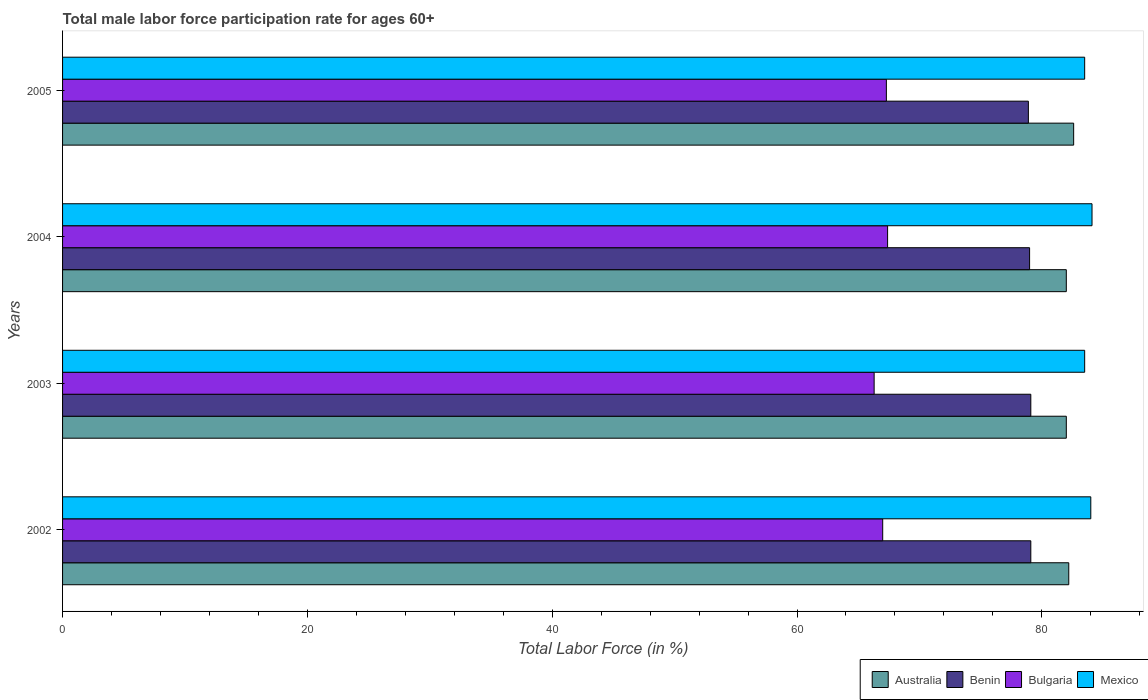How many groups of bars are there?
Offer a very short reply. 4. Are the number of bars on each tick of the Y-axis equal?
Provide a short and direct response. Yes. What is the male labor force participation rate in Australia in 2002?
Offer a very short reply. 82.2. Across all years, what is the maximum male labor force participation rate in Benin?
Keep it short and to the point. 79.1. Across all years, what is the minimum male labor force participation rate in Bulgaria?
Provide a succinct answer. 66.3. In which year was the male labor force participation rate in Mexico minimum?
Ensure brevity in your answer.  2003. What is the total male labor force participation rate in Benin in the graph?
Provide a succinct answer. 316.1. What is the difference between the male labor force participation rate in Bulgaria in 2002 and that in 2003?
Your response must be concise. 0.7. What is the difference between the male labor force participation rate in Australia in 2004 and the male labor force participation rate in Benin in 2003?
Offer a very short reply. 2.9. What is the average male labor force participation rate in Bulgaria per year?
Your answer should be compact. 67. In the year 2005, what is the difference between the male labor force participation rate in Benin and male labor force participation rate in Australia?
Keep it short and to the point. -3.7. In how many years, is the male labor force participation rate in Mexico greater than 4 %?
Offer a terse response. 4. What is the ratio of the male labor force participation rate in Bulgaria in 2003 to that in 2004?
Provide a short and direct response. 0.98. Is the male labor force participation rate in Benin in 2002 less than that in 2004?
Give a very brief answer. No. What is the difference between the highest and the second highest male labor force participation rate in Mexico?
Ensure brevity in your answer.  0.1. What is the difference between the highest and the lowest male labor force participation rate in Australia?
Your response must be concise. 0.6. In how many years, is the male labor force participation rate in Bulgaria greater than the average male labor force participation rate in Bulgaria taken over all years?
Your answer should be very brief. 2. Is the sum of the male labor force participation rate in Bulgaria in 2003 and 2005 greater than the maximum male labor force participation rate in Mexico across all years?
Offer a very short reply. Yes. Is it the case that in every year, the sum of the male labor force participation rate in Mexico and male labor force participation rate in Benin is greater than the sum of male labor force participation rate in Australia and male labor force participation rate in Bulgaria?
Keep it short and to the point. No. What does the 1st bar from the bottom in 2003 represents?
Give a very brief answer. Australia. Is it the case that in every year, the sum of the male labor force participation rate in Bulgaria and male labor force participation rate in Mexico is greater than the male labor force participation rate in Benin?
Your answer should be compact. Yes. Does the graph contain any zero values?
Give a very brief answer. No. Does the graph contain grids?
Keep it short and to the point. No. How are the legend labels stacked?
Provide a succinct answer. Horizontal. What is the title of the graph?
Your answer should be very brief. Total male labor force participation rate for ages 60+. What is the label or title of the X-axis?
Make the answer very short. Total Labor Force (in %). What is the Total Labor Force (in %) in Australia in 2002?
Offer a very short reply. 82.2. What is the Total Labor Force (in %) of Benin in 2002?
Ensure brevity in your answer.  79.1. What is the Total Labor Force (in %) in Bulgaria in 2002?
Your answer should be compact. 67. What is the Total Labor Force (in %) in Mexico in 2002?
Offer a very short reply. 84. What is the Total Labor Force (in %) of Australia in 2003?
Your answer should be compact. 82. What is the Total Labor Force (in %) of Benin in 2003?
Keep it short and to the point. 79.1. What is the Total Labor Force (in %) of Bulgaria in 2003?
Offer a terse response. 66.3. What is the Total Labor Force (in %) of Mexico in 2003?
Provide a short and direct response. 83.5. What is the Total Labor Force (in %) of Benin in 2004?
Ensure brevity in your answer.  79. What is the Total Labor Force (in %) in Bulgaria in 2004?
Keep it short and to the point. 67.4. What is the Total Labor Force (in %) of Mexico in 2004?
Your answer should be compact. 84.1. What is the Total Labor Force (in %) of Australia in 2005?
Make the answer very short. 82.6. What is the Total Labor Force (in %) in Benin in 2005?
Keep it short and to the point. 78.9. What is the Total Labor Force (in %) in Bulgaria in 2005?
Provide a succinct answer. 67.3. What is the Total Labor Force (in %) in Mexico in 2005?
Your answer should be very brief. 83.5. Across all years, what is the maximum Total Labor Force (in %) of Australia?
Make the answer very short. 82.6. Across all years, what is the maximum Total Labor Force (in %) in Benin?
Offer a terse response. 79.1. Across all years, what is the maximum Total Labor Force (in %) of Bulgaria?
Provide a short and direct response. 67.4. Across all years, what is the maximum Total Labor Force (in %) of Mexico?
Provide a short and direct response. 84.1. Across all years, what is the minimum Total Labor Force (in %) in Benin?
Make the answer very short. 78.9. Across all years, what is the minimum Total Labor Force (in %) of Bulgaria?
Give a very brief answer. 66.3. Across all years, what is the minimum Total Labor Force (in %) in Mexico?
Your response must be concise. 83.5. What is the total Total Labor Force (in %) of Australia in the graph?
Make the answer very short. 328.8. What is the total Total Labor Force (in %) in Benin in the graph?
Offer a terse response. 316.1. What is the total Total Labor Force (in %) in Bulgaria in the graph?
Keep it short and to the point. 268. What is the total Total Labor Force (in %) in Mexico in the graph?
Offer a very short reply. 335.1. What is the difference between the Total Labor Force (in %) in Australia in 2002 and that in 2003?
Offer a very short reply. 0.2. What is the difference between the Total Labor Force (in %) of Benin in 2002 and that in 2003?
Give a very brief answer. 0. What is the difference between the Total Labor Force (in %) in Australia in 2002 and that in 2004?
Ensure brevity in your answer.  0.2. What is the difference between the Total Labor Force (in %) in Benin in 2002 and that in 2004?
Offer a very short reply. 0.1. What is the difference between the Total Labor Force (in %) of Mexico in 2002 and that in 2004?
Keep it short and to the point. -0.1. What is the difference between the Total Labor Force (in %) in Australia in 2002 and that in 2005?
Offer a terse response. -0.4. What is the difference between the Total Labor Force (in %) of Benin in 2002 and that in 2005?
Offer a terse response. 0.2. What is the difference between the Total Labor Force (in %) of Mexico in 2002 and that in 2005?
Provide a short and direct response. 0.5. What is the difference between the Total Labor Force (in %) in Benin in 2003 and that in 2004?
Ensure brevity in your answer.  0.1. What is the difference between the Total Labor Force (in %) of Bulgaria in 2003 and that in 2004?
Make the answer very short. -1.1. What is the difference between the Total Labor Force (in %) of Mexico in 2003 and that in 2004?
Your answer should be very brief. -0.6. What is the difference between the Total Labor Force (in %) in Bulgaria in 2003 and that in 2005?
Keep it short and to the point. -1. What is the difference between the Total Labor Force (in %) in Mexico in 2003 and that in 2005?
Your answer should be very brief. 0. What is the difference between the Total Labor Force (in %) in Australia in 2004 and that in 2005?
Provide a short and direct response. -0.6. What is the difference between the Total Labor Force (in %) in Benin in 2004 and that in 2005?
Ensure brevity in your answer.  0.1. What is the difference between the Total Labor Force (in %) in Bulgaria in 2004 and that in 2005?
Offer a terse response. 0.1. What is the difference between the Total Labor Force (in %) of Mexico in 2004 and that in 2005?
Keep it short and to the point. 0.6. What is the difference between the Total Labor Force (in %) in Australia in 2002 and the Total Labor Force (in %) in Benin in 2003?
Provide a succinct answer. 3.1. What is the difference between the Total Labor Force (in %) of Australia in 2002 and the Total Labor Force (in %) of Bulgaria in 2003?
Make the answer very short. 15.9. What is the difference between the Total Labor Force (in %) in Australia in 2002 and the Total Labor Force (in %) in Mexico in 2003?
Ensure brevity in your answer.  -1.3. What is the difference between the Total Labor Force (in %) in Benin in 2002 and the Total Labor Force (in %) in Mexico in 2003?
Make the answer very short. -4.4. What is the difference between the Total Labor Force (in %) in Bulgaria in 2002 and the Total Labor Force (in %) in Mexico in 2003?
Your response must be concise. -16.5. What is the difference between the Total Labor Force (in %) in Australia in 2002 and the Total Labor Force (in %) in Benin in 2004?
Offer a very short reply. 3.2. What is the difference between the Total Labor Force (in %) in Australia in 2002 and the Total Labor Force (in %) in Bulgaria in 2004?
Ensure brevity in your answer.  14.8. What is the difference between the Total Labor Force (in %) in Benin in 2002 and the Total Labor Force (in %) in Mexico in 2004?
Provide a succinct answer. -5. What is the difference between the Total Labor Force (in %) of Bulgaria in 2002 and the Total Labor Force (in %) of Mexico in 2004?
Ensure brevity in your answer.  -17.1. What is the difference between the Total Labor Force (in %) of Australia in 2002 and the Total Labor Force (in %) of Mexico in 2005?
Give a very brief answer. -1.3. What is the difference between the Total Labor Force (in %) in Benin in 2002 and the Total Labor Force (in %) in Mexico in 2005?
Give a very brief answer. -4.4. What is the difference between the Total Labor Force (in %) of Bulgaria in 2002 and the Total Labor Force (in %) of Mexico in 2005?
Ensure brevity in your answer.  -16.5. What is the difference between the Total Labor Force (in %) of Australia in 2003 and the Total Labor Force (in %) of Benin in 2004?
Give a very brief answer. 3. What is the difference between the Total Labor Force (in %) in Australia in 2003 and the Total Labor Force (in %) in Mexico in 2004?
Ensure brevity in your answer.  -2.1. What is the difference between the Total Labor Force (in %) of Benin in 2003 and the Total Labor Force (in %) of Bulgaria in 2004?
Your answer should be compact. 11.7. What is the difference between the Total Labor Force (in %) of Benin in 2003 and the Total Labor Force (in %) of Mexico in 2004?
Your response must be concise. -5. What is the difference between the Total Labor Force (in %) of Bulgaria in 2003 and the Total Labor Force (in %) of Mexico in 2004?
Your answer should be very brief. -17.8. What is the difference between the Total Labor Force (in %) in Australia in 2003 and the Total Labor Force (in %) in Benin in 2005?
Ensure brevity in your answer.  3.1. What is the difference between the Total Labor Force (in %) in Benin in 2003 and the Total Labor Force (in %) in Bulgaria in 2005?
Your response must be concise. 11.8. What is the difference between the Total Labor Force (in %) in Benin in 2003 and the Total Labor Force (in %) in Mexico in 2005?
Your answer should be compact. -4.4. What is the difference between the Total Labor Force (in %) in Bulgaria in 2003 and the Total Labor Force (in %) in Mexico in 2005?
Your answer should be very brief. -17.2. What is the difference between the Total Labor Force (in %) in Australia in 2004 and the Total Labor Force (in %) in Bulgaria in 2005?
Make the answer very short. 14.7. What is the difference between the Total Labor Force (in %) of Australia in 2004 and the Total Labor Force (in %) of Mexico in 2005?
Offer a very short reply. -1.5. What is the difference between the Total Labor Force (in %) of Benin in 2004 and the Total Labor Force (in %) of Bulgaria in 2005?
Your answer should be compact. 11.7. What is the difference between the Total Labor Force (in %) of Bulgaria in 2004 and the Total Labor Force (in %) of Mexico in 2005?
Provide a succinct answer. -16.1. What is the average Total Labor Force (in %) of Australia per year?
Keep it short and to the point. 82.2. What is the average Total Labor Force (in %) in Benin per year?
Your answer should be compact. 79.03. What is the average Total Labor Force (in %) in Mexico per year?
Keep it short and to the point. 83.78. In the year 2002, what is the difference between the Total Labor Force (in %) in Benin and Total Labor Force (in %) in Bulgaria?
Your answer should be compact. 12.1. In the year 2003, what is the difference between the Total Labor Force (in %) in Australia and Total Labor Force (in %) in Benin?
Ensure brevity in your answer.  2.9. In the year 2003, what is the difference between the Total Labor Force (in %) in Australia and Total Labor Force (in %) in Bulgaria?
Keep it short and to the point. 15.7. In the year 2003, what is the difference between the Total Labor Force (in %) in Australia and Total Labor Force (in %) in Mexico?
Your response must be concise. -1.5. In the year 2003, what is the difference between the Total Labor Force (in %) in Bulgaria and Total Labor Force (in %) in Mexico?
Your answer should be compact. -17.2. In the year 2004, what is the difference between the Total Labor Force (in %) of Benin and Total Labor Force (in %) of Bulgaria?
Ensure brevity in your answer.  11.6. In the year 2004, what is the difference between the Total Labor Force (in %) in Bulgaria and Total Labor Force (in %) in Mexico?
Offer a terse response. -16.7. In the year 2005, what is the difference between the Total Labor Force (in %) of Australia and Total Labor Force (in %) of Benin?
Make the answer very short. 3.7. In the year 2005, what is the difference between the Total Labor Force (in %) of Bulgaria and Total Labor Force (in %) of Mexico?
Your answer should be compact. -16.2. What is the ratio of the Total Labor Force (in %) in Australia in 2002 to that in 2003?
Make the answer very short. 1. What is the ratio of the Total Labor Force (in %) of Benin in 2002 to that in 2003?
Your response must be concise. 1. What is the ratio of the Total Labor Force (in %) of Bulgaria in 2002 to that in 2003?
Your answer should be compact. 1.01. What is the ratio of the Total Labor Force (in %) of Mexico in 2002 to that in 2003?
Your answer should be very brief. 1.01. What is the ratio of the Total Labor Force (in %) in Benin in 2002 to that in 2004?
Provide a short and direct response. 1. What is the ratio of the Total Labor Force (in %) in Mexico in 2002 to that in 2004?
Provide a short and direct response. 1. What is the ratio of the Total Labor Force (in %) in Australia in 2002 to that in 2005?
Your answer should be compact. 1. What is the ratio of the Total Labor Force (in %) of Benin in 2003 to that in 2004?
Keep it short and to the point. 1. What is the ratio of the Total Labor Force (in %) in Bulgaria in 2003 to that in 2004?
Offer a very short reply. 0.98. What is the ratio of the Total Labor Force (in %) of Mexico in 2003 to that in 2004?
Keep it short and to the point. 0.99. What is the ratio of the Total Labor Force (in %) in Bulgaria in 2003 to that in 2005?
Ensure brevity in your answer.  0.99. What is the ratio of the Total Labor Force (in %) in Australia in 2004 to that in 2005?
Your answer should be compact. 0.99. What is the ratio of the Total Labor Force (in %) of Bulgaria in 2004 to that in 2005?
Give a very brief answer. 1. What is the ratio of the Total Labor Force (in %) in Mexico in 2004 to that in 2005?
Provide a succinct answer. 1.01. What is the difference between the highest and the second highest Total Labor Force (in %) of Bulgaria?
Your answer should be very brief. 0.1. What is the difference between the highest and the second highest Total Labor Force (in %) of Mexico?
Keep it short and to the point. 0.1. What is the difference between the highest and the lowest Total Labor Force (in %) of Australia?
Provide a succinct answer. 0.6. What is the difference between the highest and the lowest Total Labor Force (in %) in Bulgaria?
Give a very brief answer. 1.1. What is the difference between the highest and the lowest Total Labor Force (in %) in Mexico?
Your answer should be very brief. 0.6. 